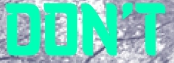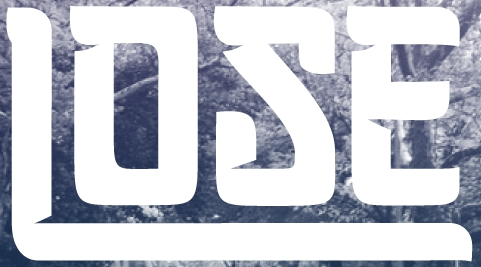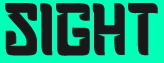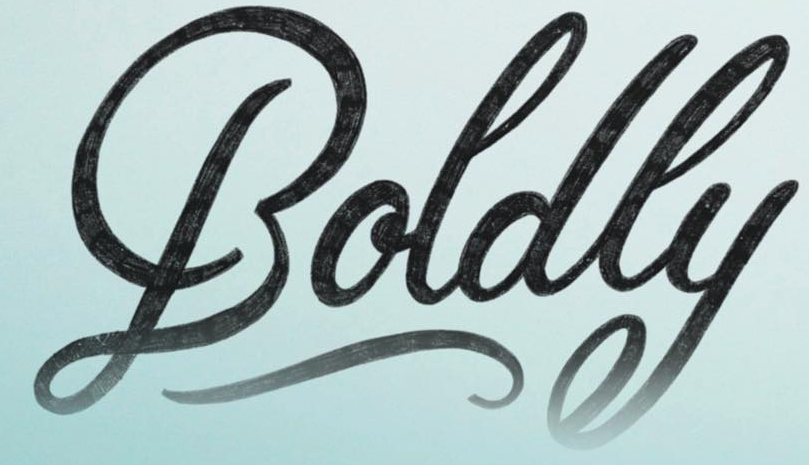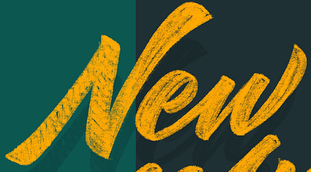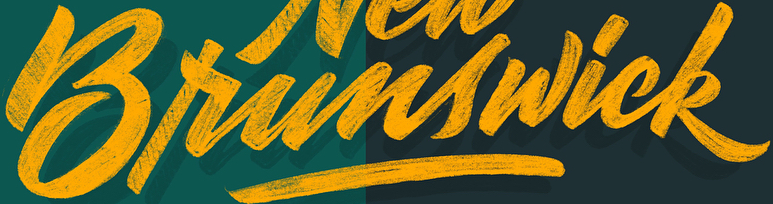What words can you see in these images in sequence, separated by a semicolon? DON'T; LOSE; SIGHT; Boldly; New; Brunswick 